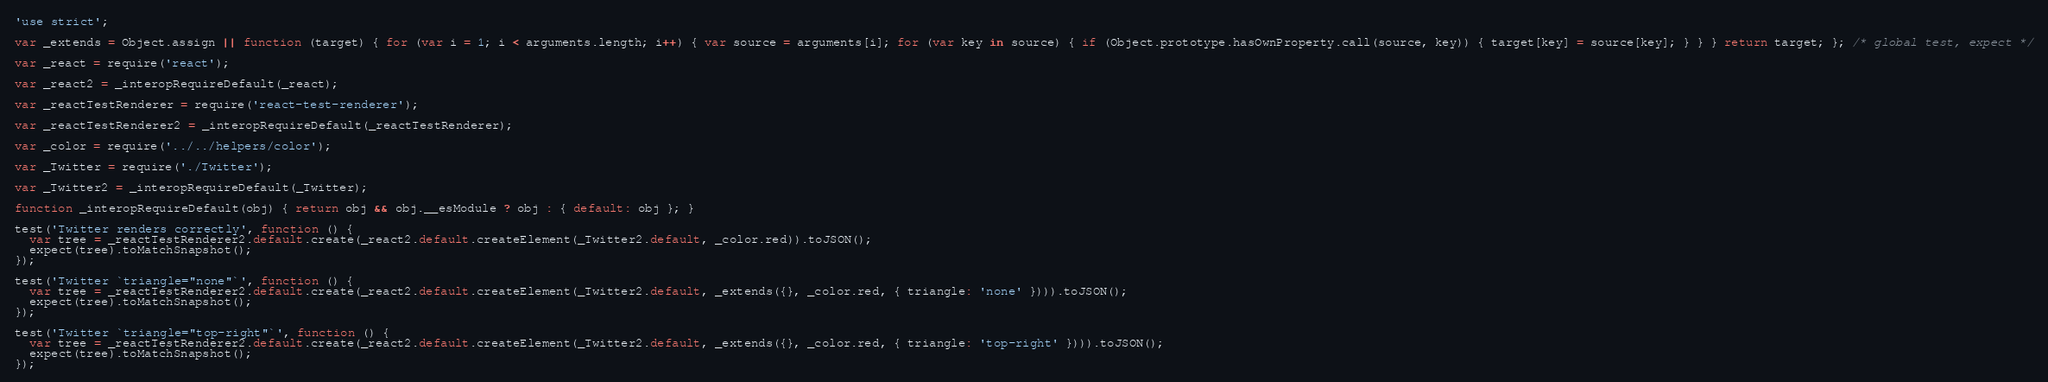<code> <loc_0><loc_0><loc_500><loc_500><_JavaScript_>'use strict';

var _extends = Object.assign || function (target) { for (var i = 1; i < arguments.length; i++) { var source = arguments[i]; for (var key in source) { if (Object.prototype.hasOwnProperty.call(source, key)) { target[key] = source[key]; } } } return target; }; /* global test, expect */

var _react = require('react');

var _react2 = _interopRequireDefault(_react);

var _reactTestRenderer = require('react-test-renderer');

var _reactTestRenderer2 = _interopRequireDefault(_reactTestRenderer);

var _color = require('../../helpers/color');

var _Twitter = require('./Twitter');

var _Twitter2 = _interopRequireDefault(_Twitter);

function _interopRequireDefault(obj) { return obj && obj.__esModule ? obj : { default: obj }; }

test('Twitter renders correctly', function () {
  var tree = _reactTestRenderer2.default.create(_react2.default.createElement(_Twitter2.default, _color.red)).toJSON();
  expect(tree).toMatchSnapshot();
});

test('Twitter `triangle="none"`', function () {
  var tree = _reactTestRenderer2.default.create(_react2.default.createElement(_Twitter2.default, _extends({}, _color.red, { triangle: 'none' }))).toJSON();
  expect(tree).toMatchSnapshot();
});

test('Twitter `triangle="top-right"`', function () {
  var tree = _reactTestRenderer2.default.create(_react2.default.createElement(_Twitter2.default, _extends({}, _color.red, { triangle: 'top-right' }))).toJSON();
  expect(tree).toMatchSnapshot();
});</code> 